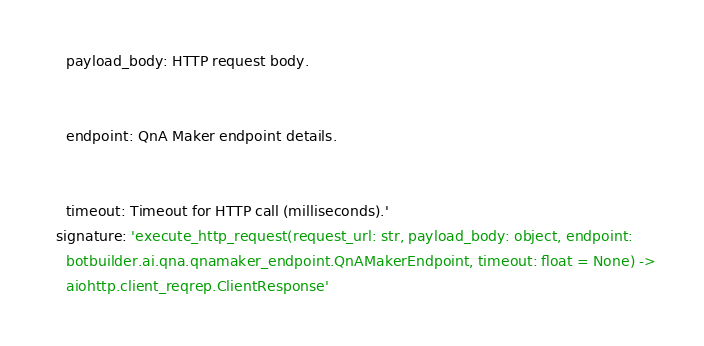<code> <loc_0><loc_0><loc_500><loc_500><_YAML_>    payload_body: HTTP request body.


    endpoint: QnA Maker endpoint details.


    timeout: Timeout for HTTP call (milliseconds).'
  signature: 'execute_http_request(request_url: str, payload_body: object, endpoint:
    botbuilder.ai.qna.qnamaker_endpoint.QnAMakerEndpoint, timeout: float = None) ->
    aiohttp.client_reqrep.ClientResponse'
</code> 